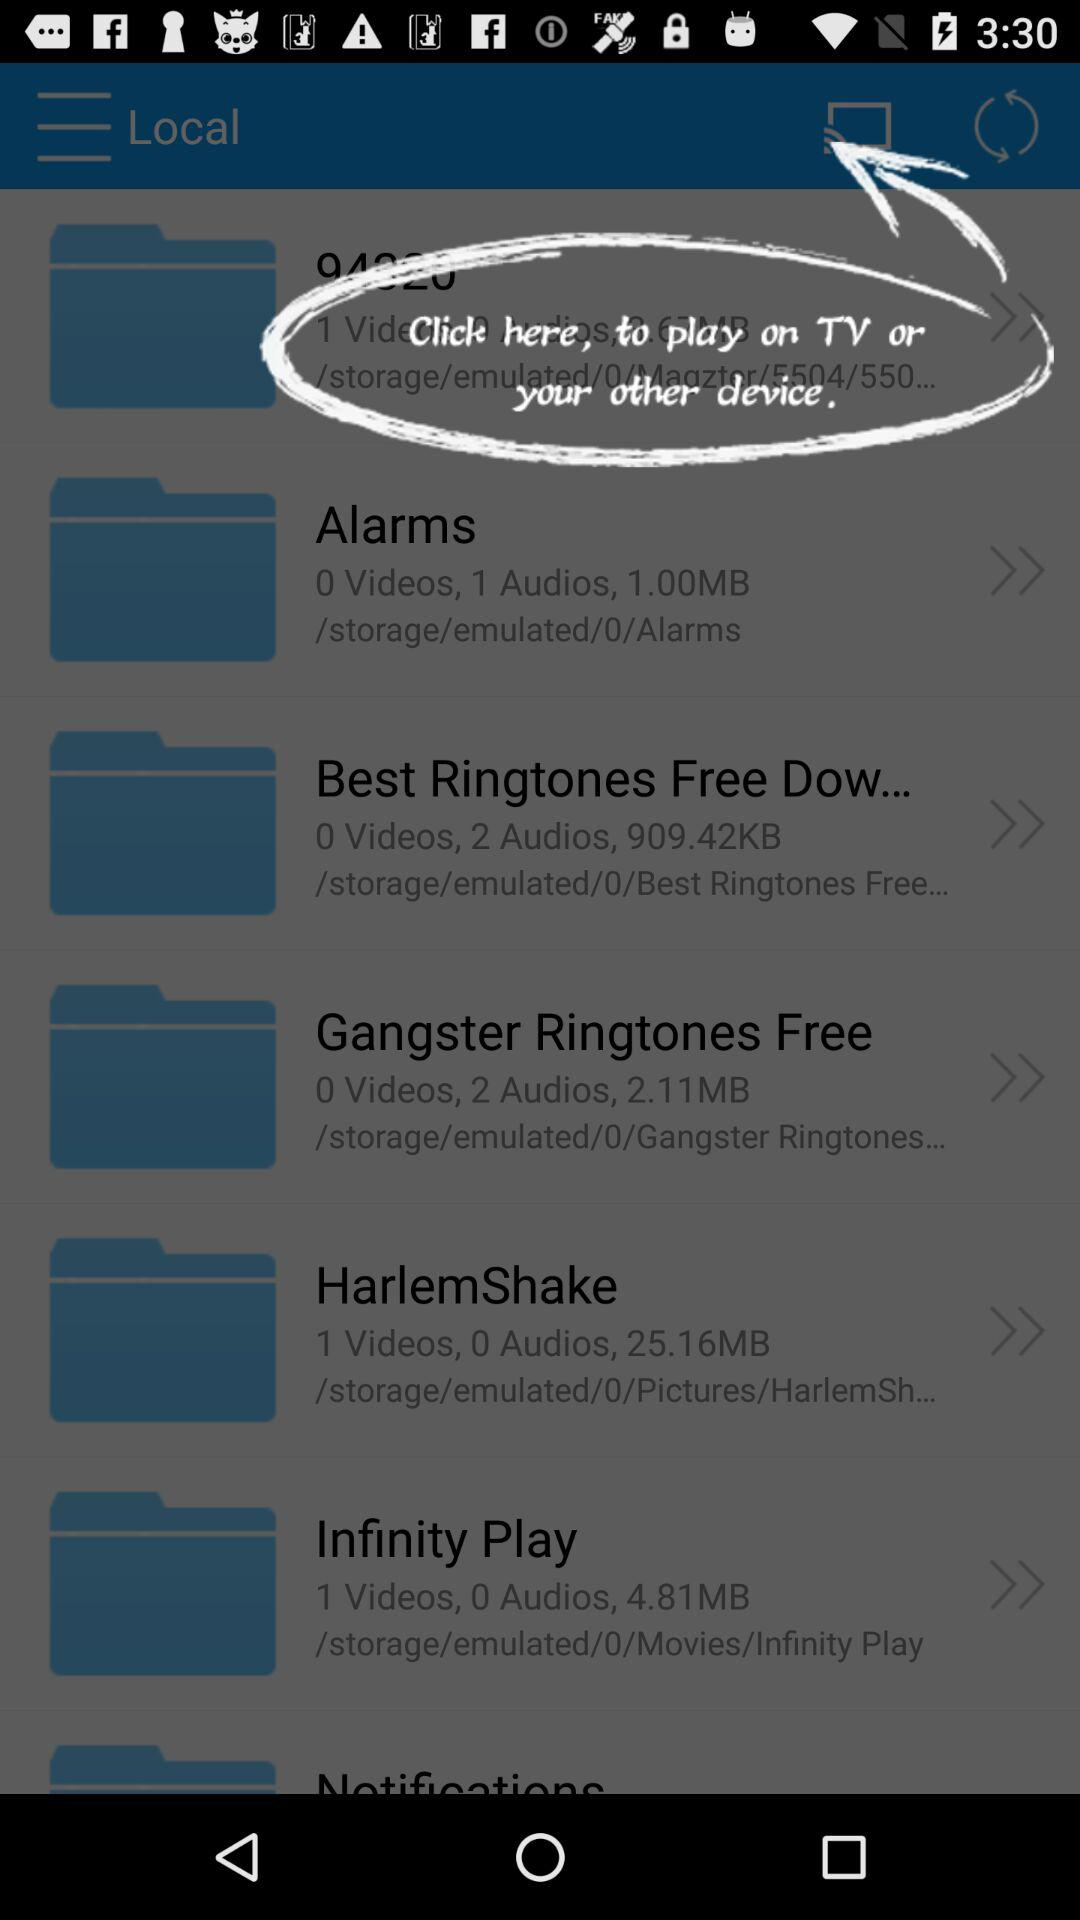What is the number of audios in "Gangster Ringtones Free"? The number of audios in "Gangster Ringtones Free" is 2. 